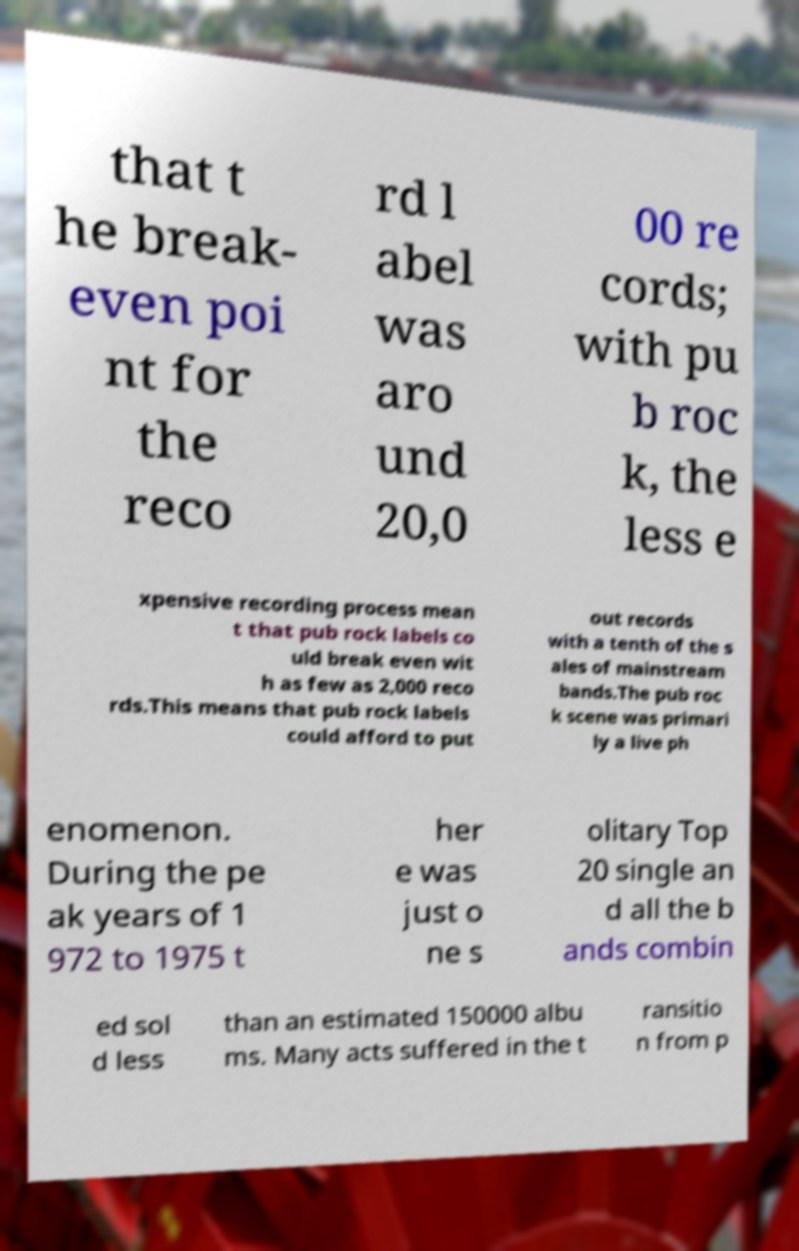I need the written content from this picture converted into text. Can you do that? that t he break- even poi nt for the reco rd l abel was aro und 20,0 00 re cords; with pu b roc k, the less e xpensive recording process mean t that pub rock labels co uld break even wit h as few as 2,000 reco rds.This means that pub rock labels could afford to put out records with a tenth of the s ales of mainstream bands.The pub roc k scene was primari ly a live ph enomenon. During the pe ak years of 1 972 to 1975 t her e was just o ne s olitary Top 20 single an d all the b ands combin ed sol d less than an estimated 150000 albu ms. Many acts suffered in the t ransitio n from p 